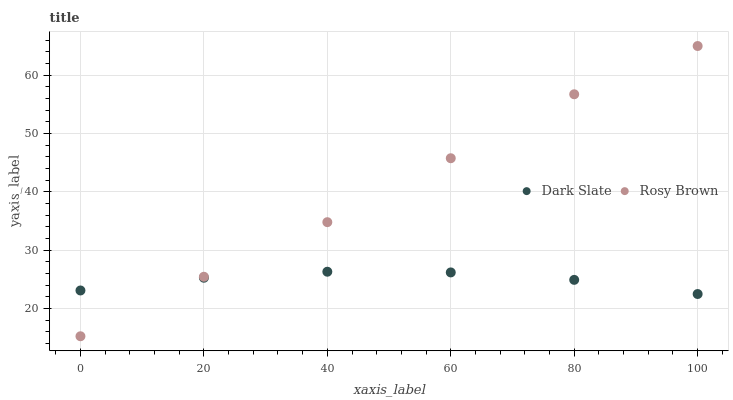Does Dark Slate have the minimum area under the curve?
Answer yes or no. Yes. Does Rosy Brown have the maximum area under the curve?
Answer yes or no. Yes. Does Rosy Brown have the minimum area under the curve?
Answer yes or no. No. Is Dark Slate the smoothest?
Answer yes or no. Yes. Is Rosy Brown the roughest?
Answer yes or no. Yes. Is Rosy Brown the smoothest?
Answer yes or no. No. Does Rosy Brown have the lowest value?
Answer yes or no. Yes. Does Rosy Brown have the highest value?
Answer yes or no. Yes. Does Dark Slate intersect Rosy Brown?
Answer yes or no. Yes. Is Dark Slate less than Rosy Brown?
Answer yes or no. No. Is Dark Slate greater than Rosy Brown?
Answer yes or no. No. 